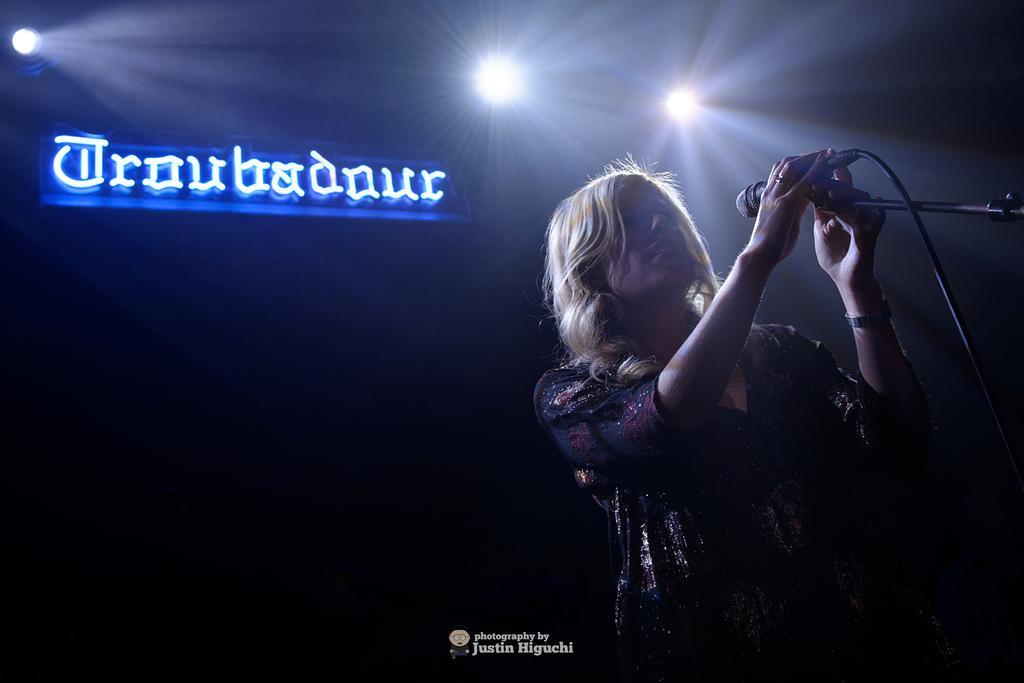Please provide a concise description of this image. In this image we can see a woman standing. On the right side of the image we can see a microphone with cable placed on a stand. In the background, we can see a board with some text and some lights. 